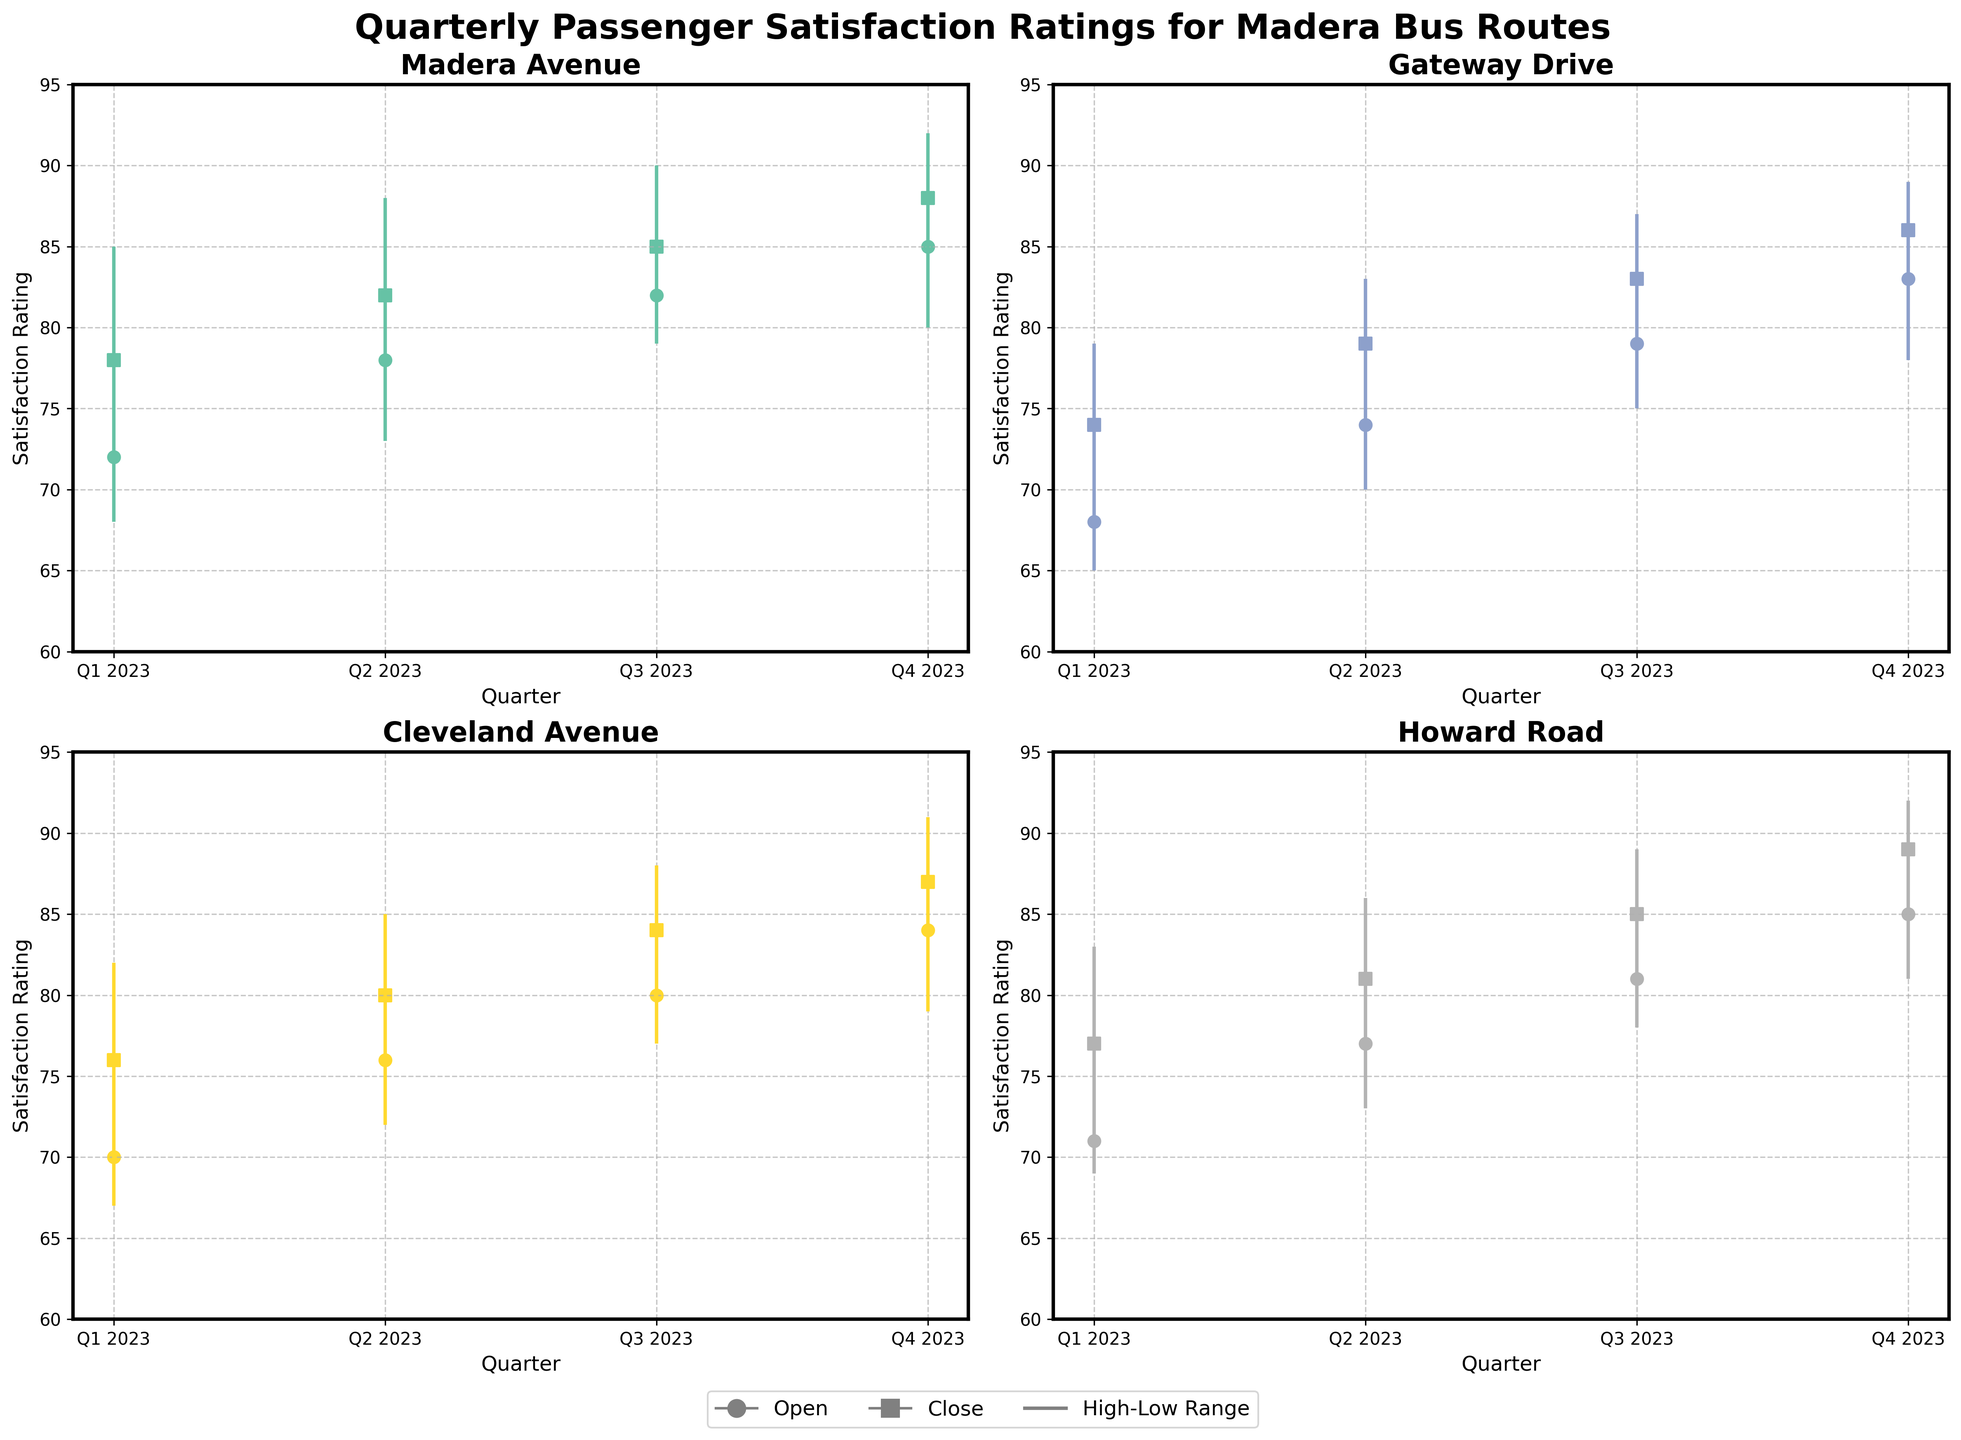What's the title of the figure? The title of the figure is displayed at the top. It provides an overview of what the chart is about.
Answer: Quarterly Passenger Satisfaction Ratings for Madera Bus Routes How many routes are displayed in the figure? The figure contains four subplots, each corresponding to a different bus route.
Answer: Four Which route had the highest closing satisfaction rating in Q4 2023? In Q4 2023, Howard Road had a closing satisfaction rating of 89, which is the highest among all routes in that quarter.
Answer: Howard Road What was the high satisfaction rating for Cleveland Avenue in Q2 2023? For Cleveland Avenue in Q2 2023, the high satisfaction rating point is marked at 85.
Answer: 85 How does the closing satisfaction rating of Gateway Drive compare between Q2 2023 and Q4 2023? The closing satisfaction rating for Gateway Drive in Q2 2023 is 79 while in Q4 2023, it is 86. Therefore, it increased by 7 points.
Answer: Increased by 7 Which route showed the most overall improvement from Q1 to Q4 in 2023? By comparing the closing values, Howard Road went from a rating of 77 in Q1 to 89 in Q4, showing a total improvement of 12 points.
Answer: Howard Road What is the range of satisfaction ratings (High minus Low) for Madera Avenue in Q3 2023? In Q3 2023, Madera Avenue had a high of 90 and a low of 79. The range is calculated as 90 - 79 = 11.
Answer: 11 Which quarter had the lowest opening satisfaction rating for all routes combined? By comparing all opening satisfaction ratings, Gateway Drive in Q1 2023 had the lowest opening at 68.
Answer: Q1 2023 Did any route experience a decrease in closing satisfaction rating in any quarter of 2023? Upon checking the closing satisfaction ratings for each route across all quarters, no route shows a decrease in any quarter of 2023.
Answer: No For Howard Road, what was the difference between the highest and lowest satisfaction ratings in Q3 2023? In Q3 2023, Howard Road had a high of 89 and a low of 78. The difference is calculated as 89 - 78 = 11.
Answer: 11 